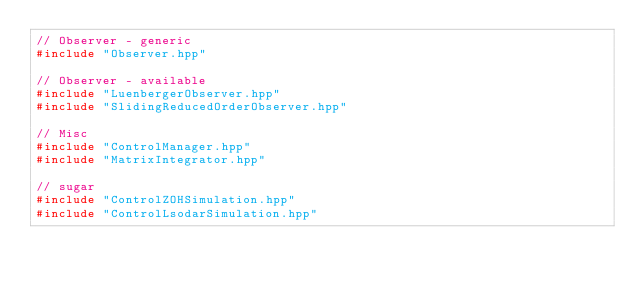Convert code to text. <code><loc_0><loc_0><loc_500><loc_500><_C++_>// Observer - generic
#include "Observer.hpp"

// Observer - available
#include "LuenbergerObserver.hpp"
#include "SlidingReducedOrderObserver.hpp"

// Misc
#include "ControlManager.hpp"
#include "MatrixIntegrator.hpp"

// sugar
#include "ControlZOHSimulation.hpp"
#include "ControlLsodarSimulation.hpp"

</code> 